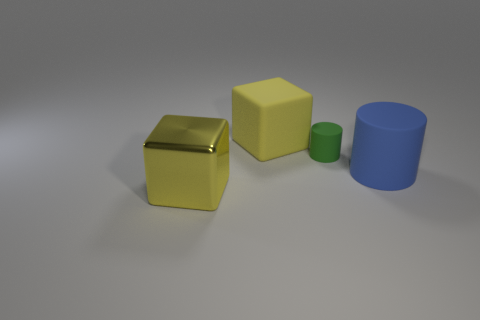Add 2 big yellow objects. How many objects exist? 6 Subtract 0 red cubes. How many objects are left? 4 Subtract all large red metal balls. Subtract all big blue matte objects. How many objects are left? 3 Add 3 large yellow metallic objects. How many large yellow metallic objects are left? 4 Add 1 tiny matte things. How many tiny matte things exist? 2 